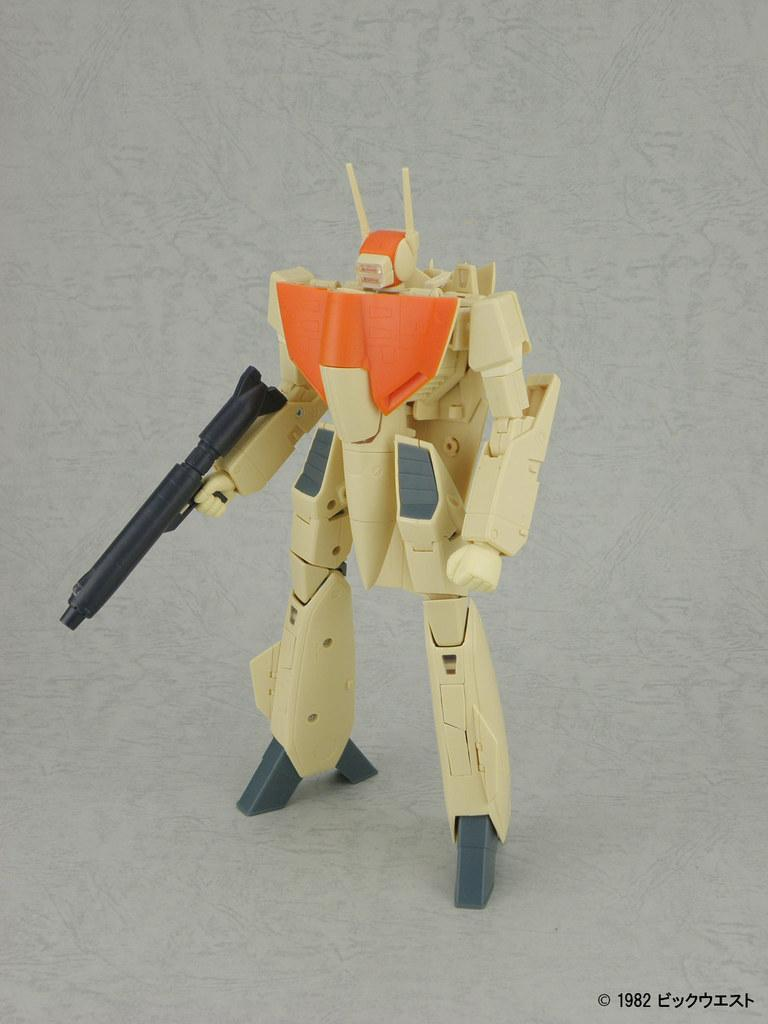What type of toy is in the picture? There is a robot toy in the picture. What colors can be seen on the robot toy? The robot toy has orange and black colors. Are there any other colors on the robot toy? Yes, the robot toy has other colors as well. Can you see any teeth on the robot toy in the image? No, there are no teeth visible on the robot toy in the image. Is there a rainstorm happening in the image? There is no mention of rain or rainstorm in the provided facts, and the image does not depict any weather conditions. 